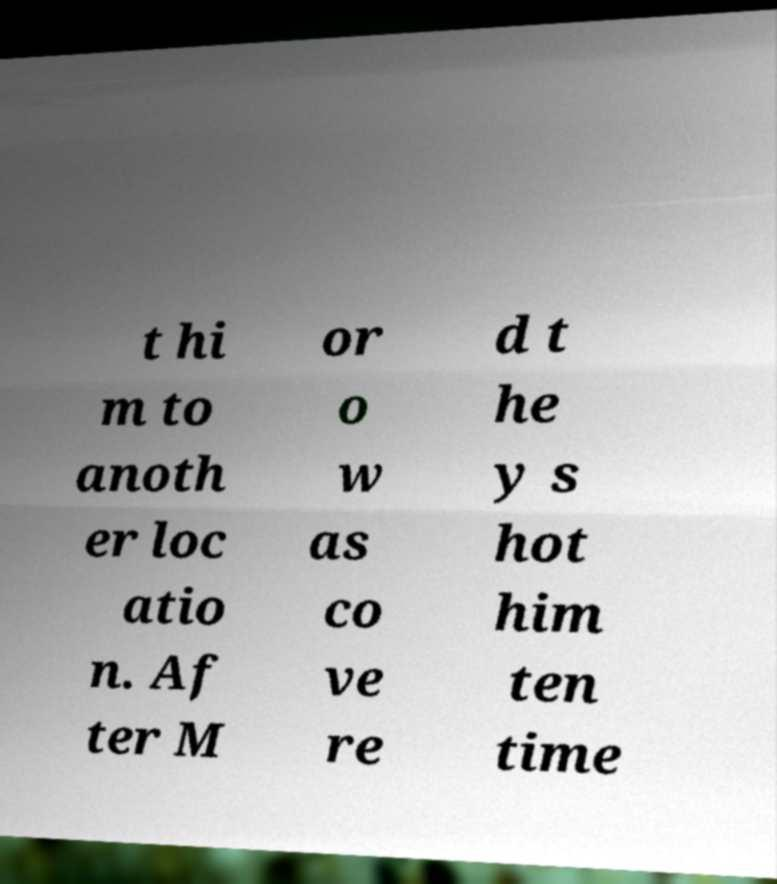For documentation purposes, I need the text within this image transcribed. Could you provide that? t hi m to anoth er loc atio n. Af ter M or o w as co ve re d t he y s hot him ten time 